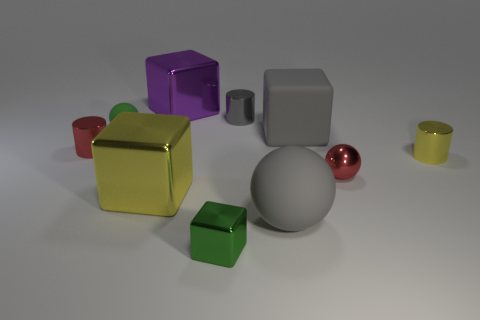What color is the big thing that is the same shape as the small green rubber thing?
Provide a succinct answer. Gray. Is there any other thing that has the same color as the metal sphere?
Offer a terse response. Yes. What is the shape of the small object that is both left of the tiny red sphere and in front of the small yellow shiny cylinder?
Provide a succinct answer. Cube. There is a yellow shiny object behind the big yellow metallic thing; what size is it?
Offer a terse response. Small. How many green matte balls are behind the small sphere to the left of the purple thing that is behind the yellow shiny cylinder?
Keep it short and to the point. 0. There is a big yellow cube; are there any yellow metal cubes in front of it?
Give a very brief answer. No. What number of other objects are there of the same size as the metallic sphere?
Give a very brief answer. 5. There is a object that is in front of the big yellow shiny block and behind the small green block; what is its material?
Give a very brief answer. Rubber. Does the yellow metal object that is on the right side of the tiny block have the same shape as the red metal thing that is right of the large yellow object?
Keep it short and to the point. No. The big gray thing that is to the left of the big cube that is to the right of the tiny gray object that is right of the tiny metal cube is what shape?
Offer a terse response. Sphere. 